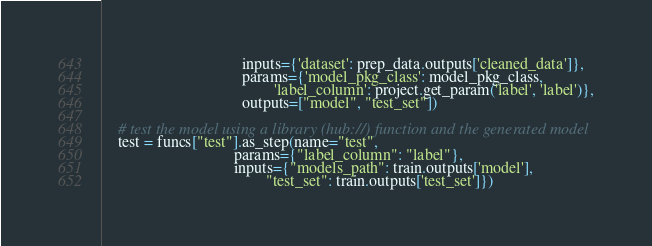<code> <loc_0><loc_0><loc_500><loc_500><_Python_>                                   inputs={'dataset': prep_data.outputs['cleaned_data']},
                                   params={'model_pkg_class': model_pkg_class,
                                           'label_column': project.get_param('label', 'label')},
                                   outputs=["model", "test_set"])

    # test the model using a library (hub://) function and the generated model
    test = funcs["test"].as_step(name="test",
                                 params={"label_column": "label"},
                                 inputs={"models_path": train.outputs['model'],
                                         "test_set": train.outputs['test_set']})
</code> 